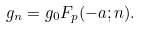Convert formula to latex. <formula><loc_0><loc_0><loc_500><loc_500>g _ { n } = g _ { 0 } F _ { p } ( - a ; n ) .</formula> 